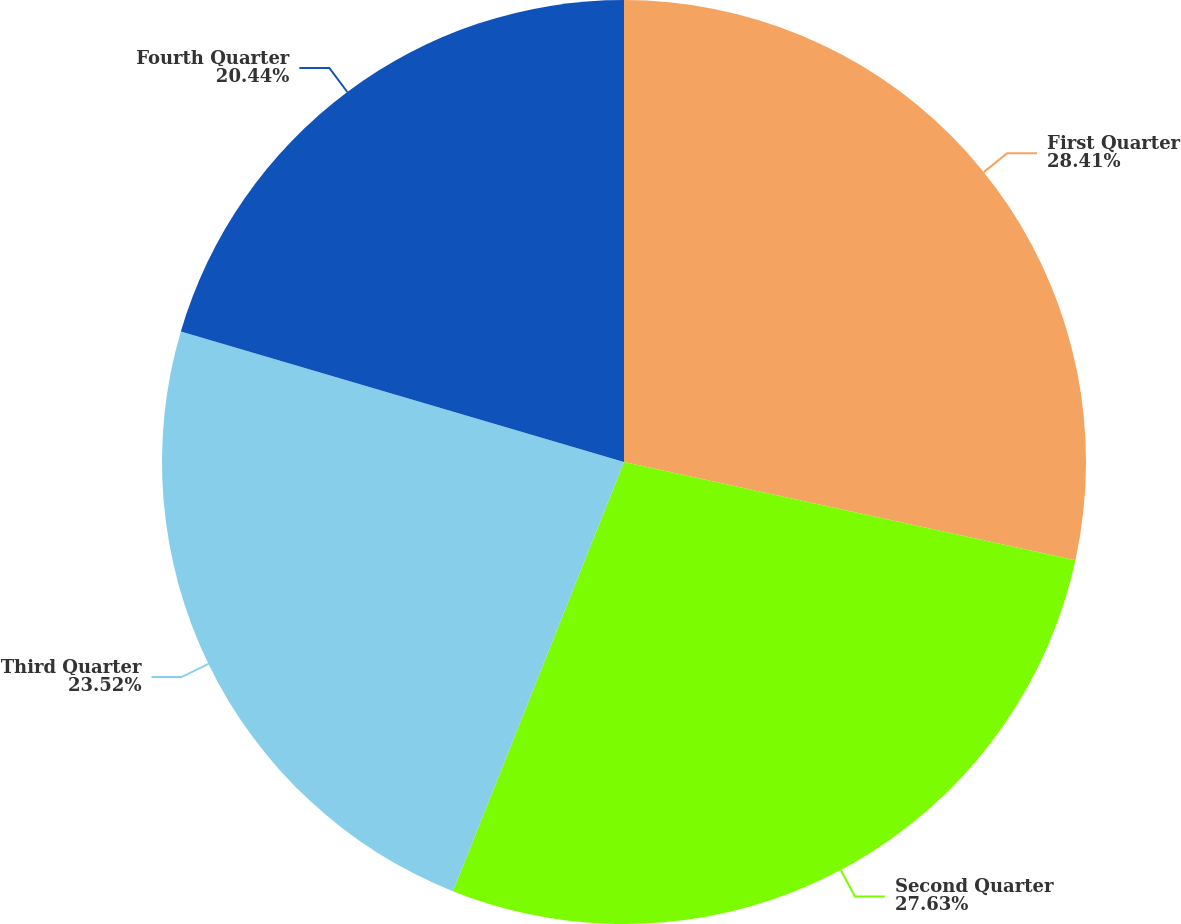Convert chart. <chart><loc_0><loc_0><loc_500><loc_500><pie_chart><fcel>First Quarter<fcel>Second Quarter<fcel>Third Quarter<fcel>Fourth Quarter<nl><fcel>28.41%<fcel>27.63%<fcel>23.52%<fcel>20.44%<nl></chart> 